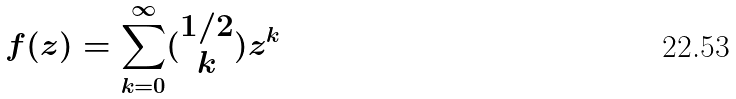Convert formula to latex. <formula><loc_0><loc_0><loc_500><loc_500>f ( z ) = \sum _ { k = 0 } ^ { \infty } ( \begin{matrix} 1 / 2 \\ k \end{matrix} ) z ^ { k }</formula> 